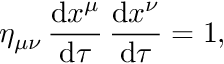Convert formula to latex. <formula><loc_0><loc_0><loc_500><loc_500>\eta _ { \mu \nu } \, \frac { d x ^ { \mu } } { d \tau } \, \frac { d x ^ { \nu } } { d \tau } = 1 ,</formula> 